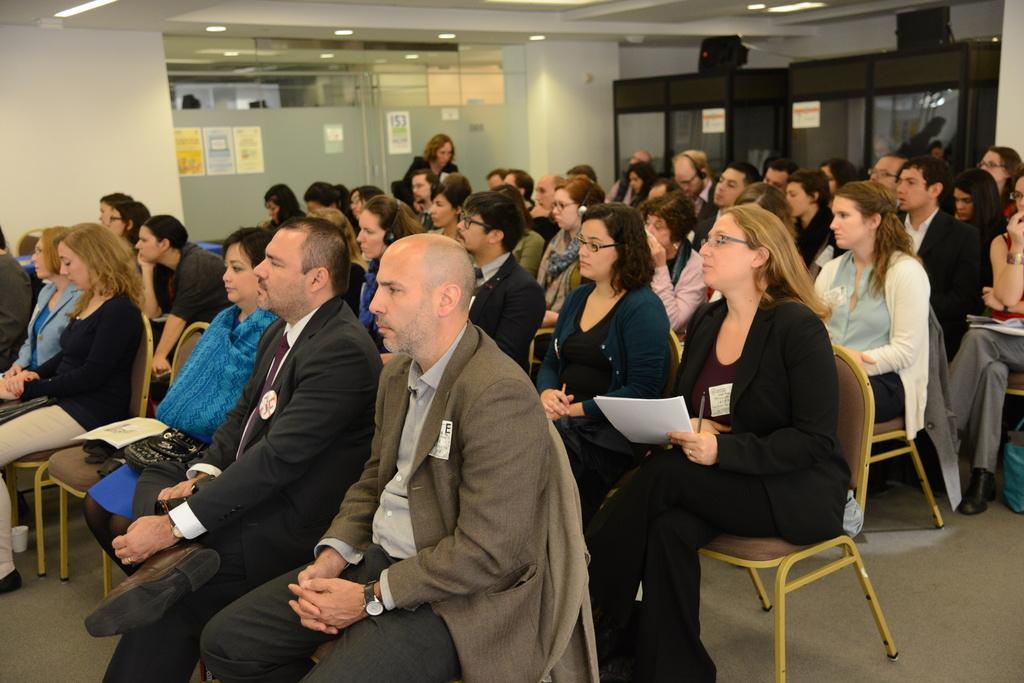Please provide a concise description of this image. In this picture there are several people sitting in a chair. In the background we observe a glass door and two wooden compartments ,on top of which two black boxes are placed. The picture is clicked inside a conference hall. 